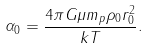Convert formula to latex. <formula><loc_0><loc_0><loc_500><loc_500>\alpha _ { 0 } = \frac { 4 \pi G \mu m _ { p } \rho _ { 0 } r _ { 0 } ^ { 2 } } { k T } .</formula> 